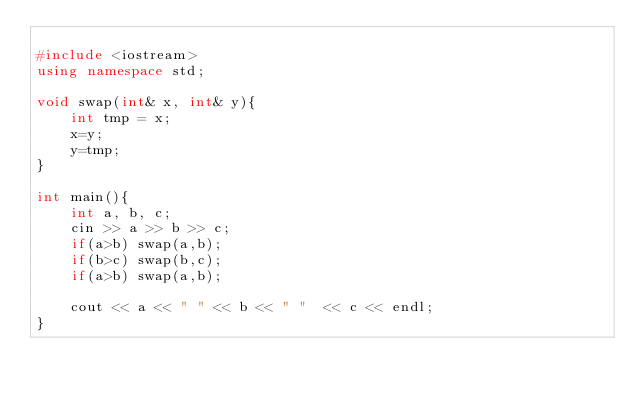<code> <loc_0><loc_0><loc_500><loc_500><_C++_>
#include <iostream>
using namespace std;

void swap(int& x, int& y){
	int tmp = x;
	x=y;
	y=tmp;
}

int main(){
	int a, b, c;
	cin >> a >> b >> c;
	if(a>b) swap(a,b);
	if(b>c) swap(b,c);
	if(a>b) swap(a,b);

	cout << a << " " << b << " "  << c << endl;
}
</code> 